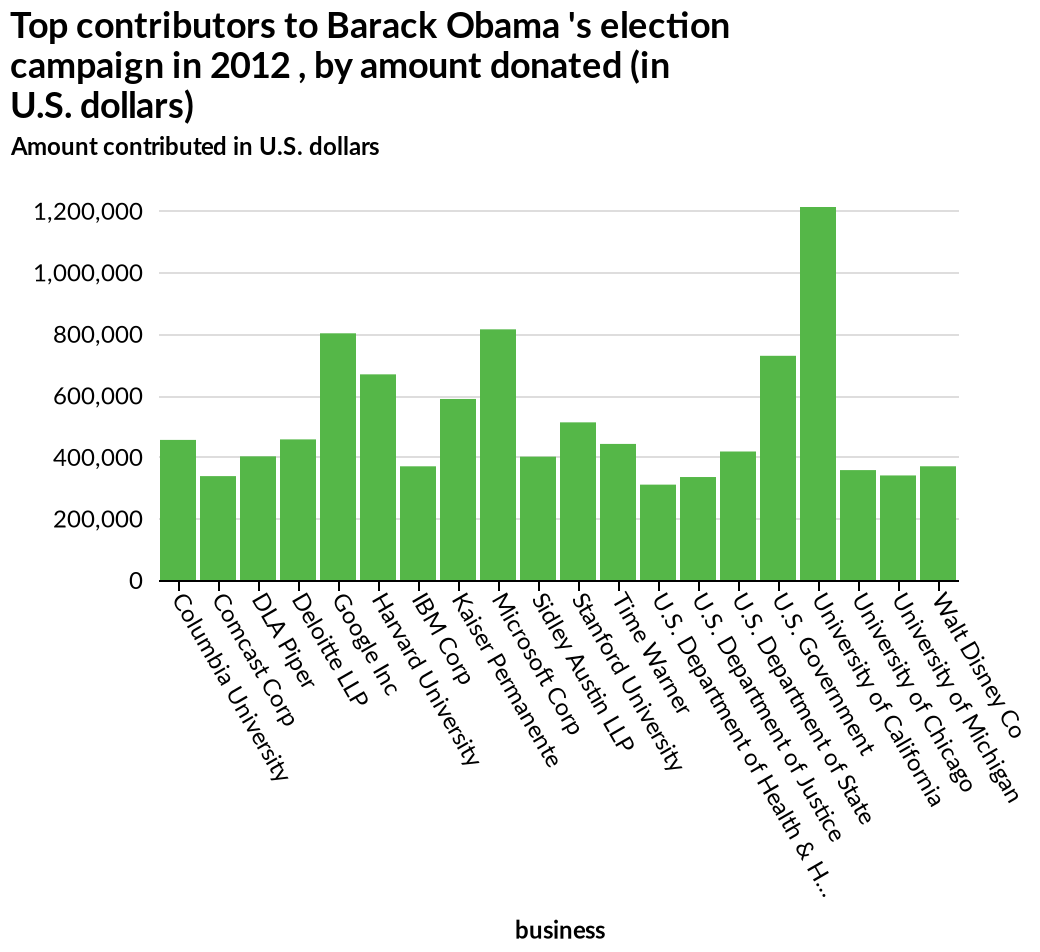<image>
Who were the top contributors to Barack Obama's election campaign in 2012?  The top contributors to Barack Obama's election campaign in 2012 are shown on the bar graph but specific names are not provided in the description. Describe the following image in detail Top contributors to Barack Obama 's election campaign in 2012 , by amount donated (in U.S. dollars) is a bar graph. The x-axis measures business as categorical scale starting at Columbia University and ending at Walt Disney Co while the y-axis measures Amount contributed in U.S. dollars along linear scale of range 0 to 1,200,000. Are all companies and universities measured similarly?  Yes, every company and university seems constantly around the same measure except for the University of California. Which business contributed the least amount to Barack Obama's election campaign in 2012? The business that contributed the least amount to Barack Obama's election campaign in 2012 is not mentioned in the description. Is the University of California consistently different from other companies and universities? Yes, according to the description, the University of California is constantly an outlier in terms of measures. Can you name the university that doesn't follow the general measure pattern? The University of California is the only university that doesn't follow the general measure pattern. 